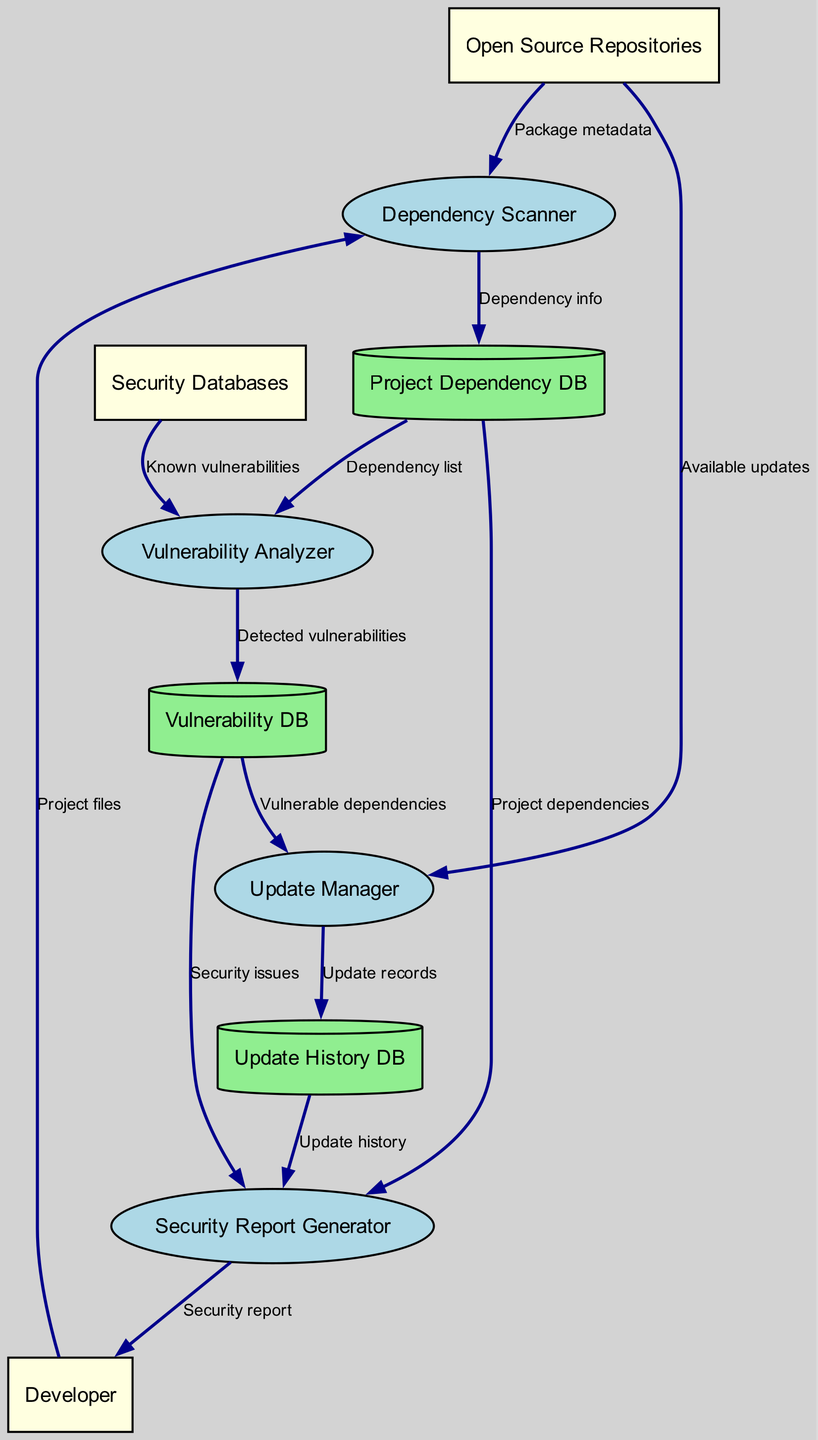What are the external entities in the diagram? The external entities listed are Developer, Open Source Repositories, and Security Databases. These entities interact with the processes within the system.
Answer: Developer, Open Source Repositories, Security Databases How many data stores are present in the diagram? The diagram specifies three data stores: Project Dependency DB, Vulnerability DB, and Update History DB.
Answer: 3 What flows from the Vulnerability Analyzer to the Vulnerability DB? The flow from the Vulnerability Analyzer to the Vulnerability DB represents the detected vulnerabilities identified during the analysis process.
Answer: Detected vulnerabilities Which process generates the final security report? The Security Report Generator is responsible for producing the final security report based on various inputs from other processes and data stores.
Answer: Security Report Generator How does the Update Manager receive input for vulnerable dependencies? The Update Manager receives input for vulnerable dependencies from the Vulnerability DB, which contains the details about the vulnerabilities identified in dependencies.
Answer: Vulnerability DB What is the purpose of the Dependency Scanner? The purpose of the Dependency Scanner is to analyze project files and gather information about dependencies, which is then stored in the Project Dependency DB.
Answer: Analyze project files What are the sources of updates for the Update Manager? The Update Manager gathers available updates from Open Source Repositories, where the latest versions of packages are hosted.
Answer: Open Source Repositories How many processes are in the diagram? There are four processes in the diagram: Dependency Scanner, Vulnerability Analyzer, Update Manager, and Security Report Generator.
Answer: 4 What is the first step after a Developer submits project files? The first step after a Developer submits project files is that the Dependency Scanner processes these files to extract dependency information.
Answer: Dependency Scanner 